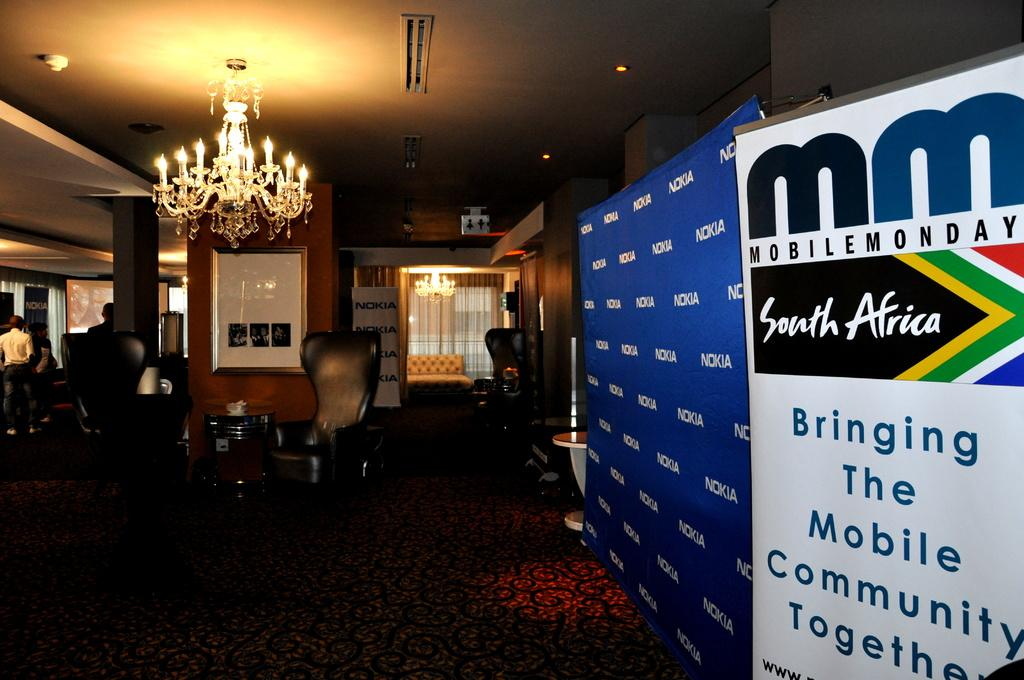<image>
Present a compact description of the photo's key features. A big sign that says MobileMonday is to the right of a blue wall with Nokia written all over it. 